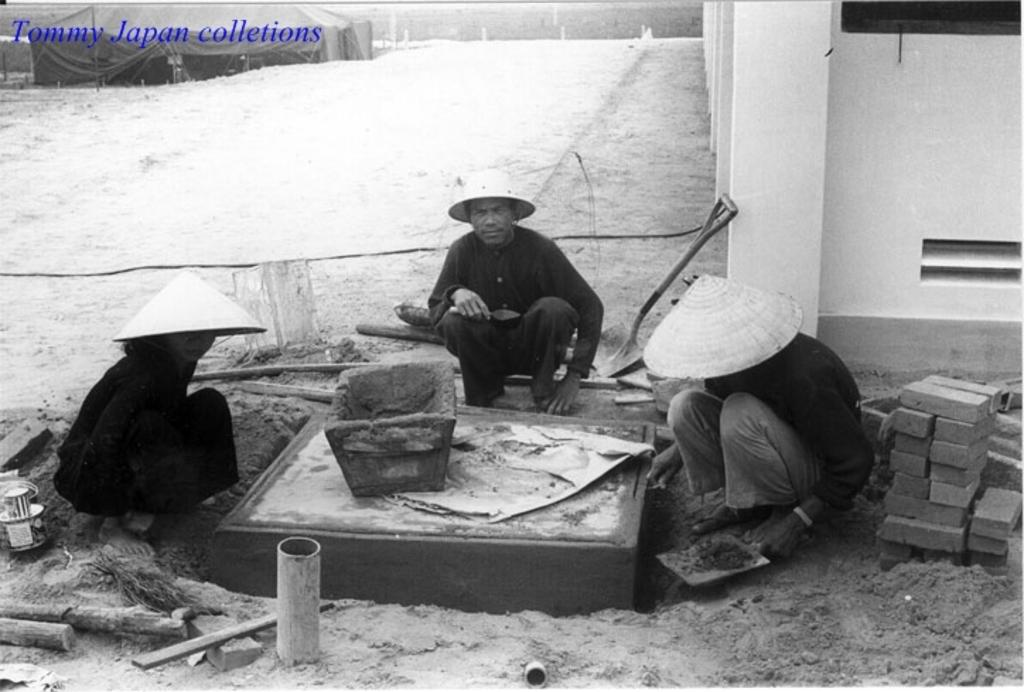What is the color scheme of the image? The image is black and white. What can be seen in the image besides the color scheme? There are people, a tent, and a wall visible in the image. Can you describe the presence of any text or markings in the image? There is a watermark in the top left corner of the image. Where is the park located in the image? There is no park present in the image. What type of pot is being used by the people in the image? There is no pot visible in the image. 